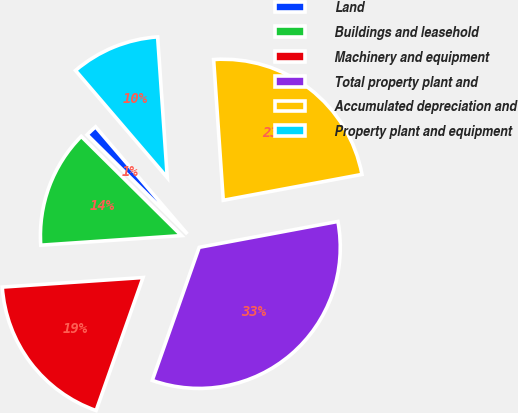Convert chart to OTSL. <chart><loc_0><loc_0><loc_500><loc_500><pie_chart><fcel>Land<fcel>Buildings and leasehold<fcel>Machinery and equipment<fcel>Total property plant and<fcel>Accumulated depreciation and<fcel>Property plant and equipment<nl><fcel>1.31%<fcel>13.5%<fcel>18.52%<fcel>33.33%<fcel>23.15%<fcel>10.18%<nl></chart> 